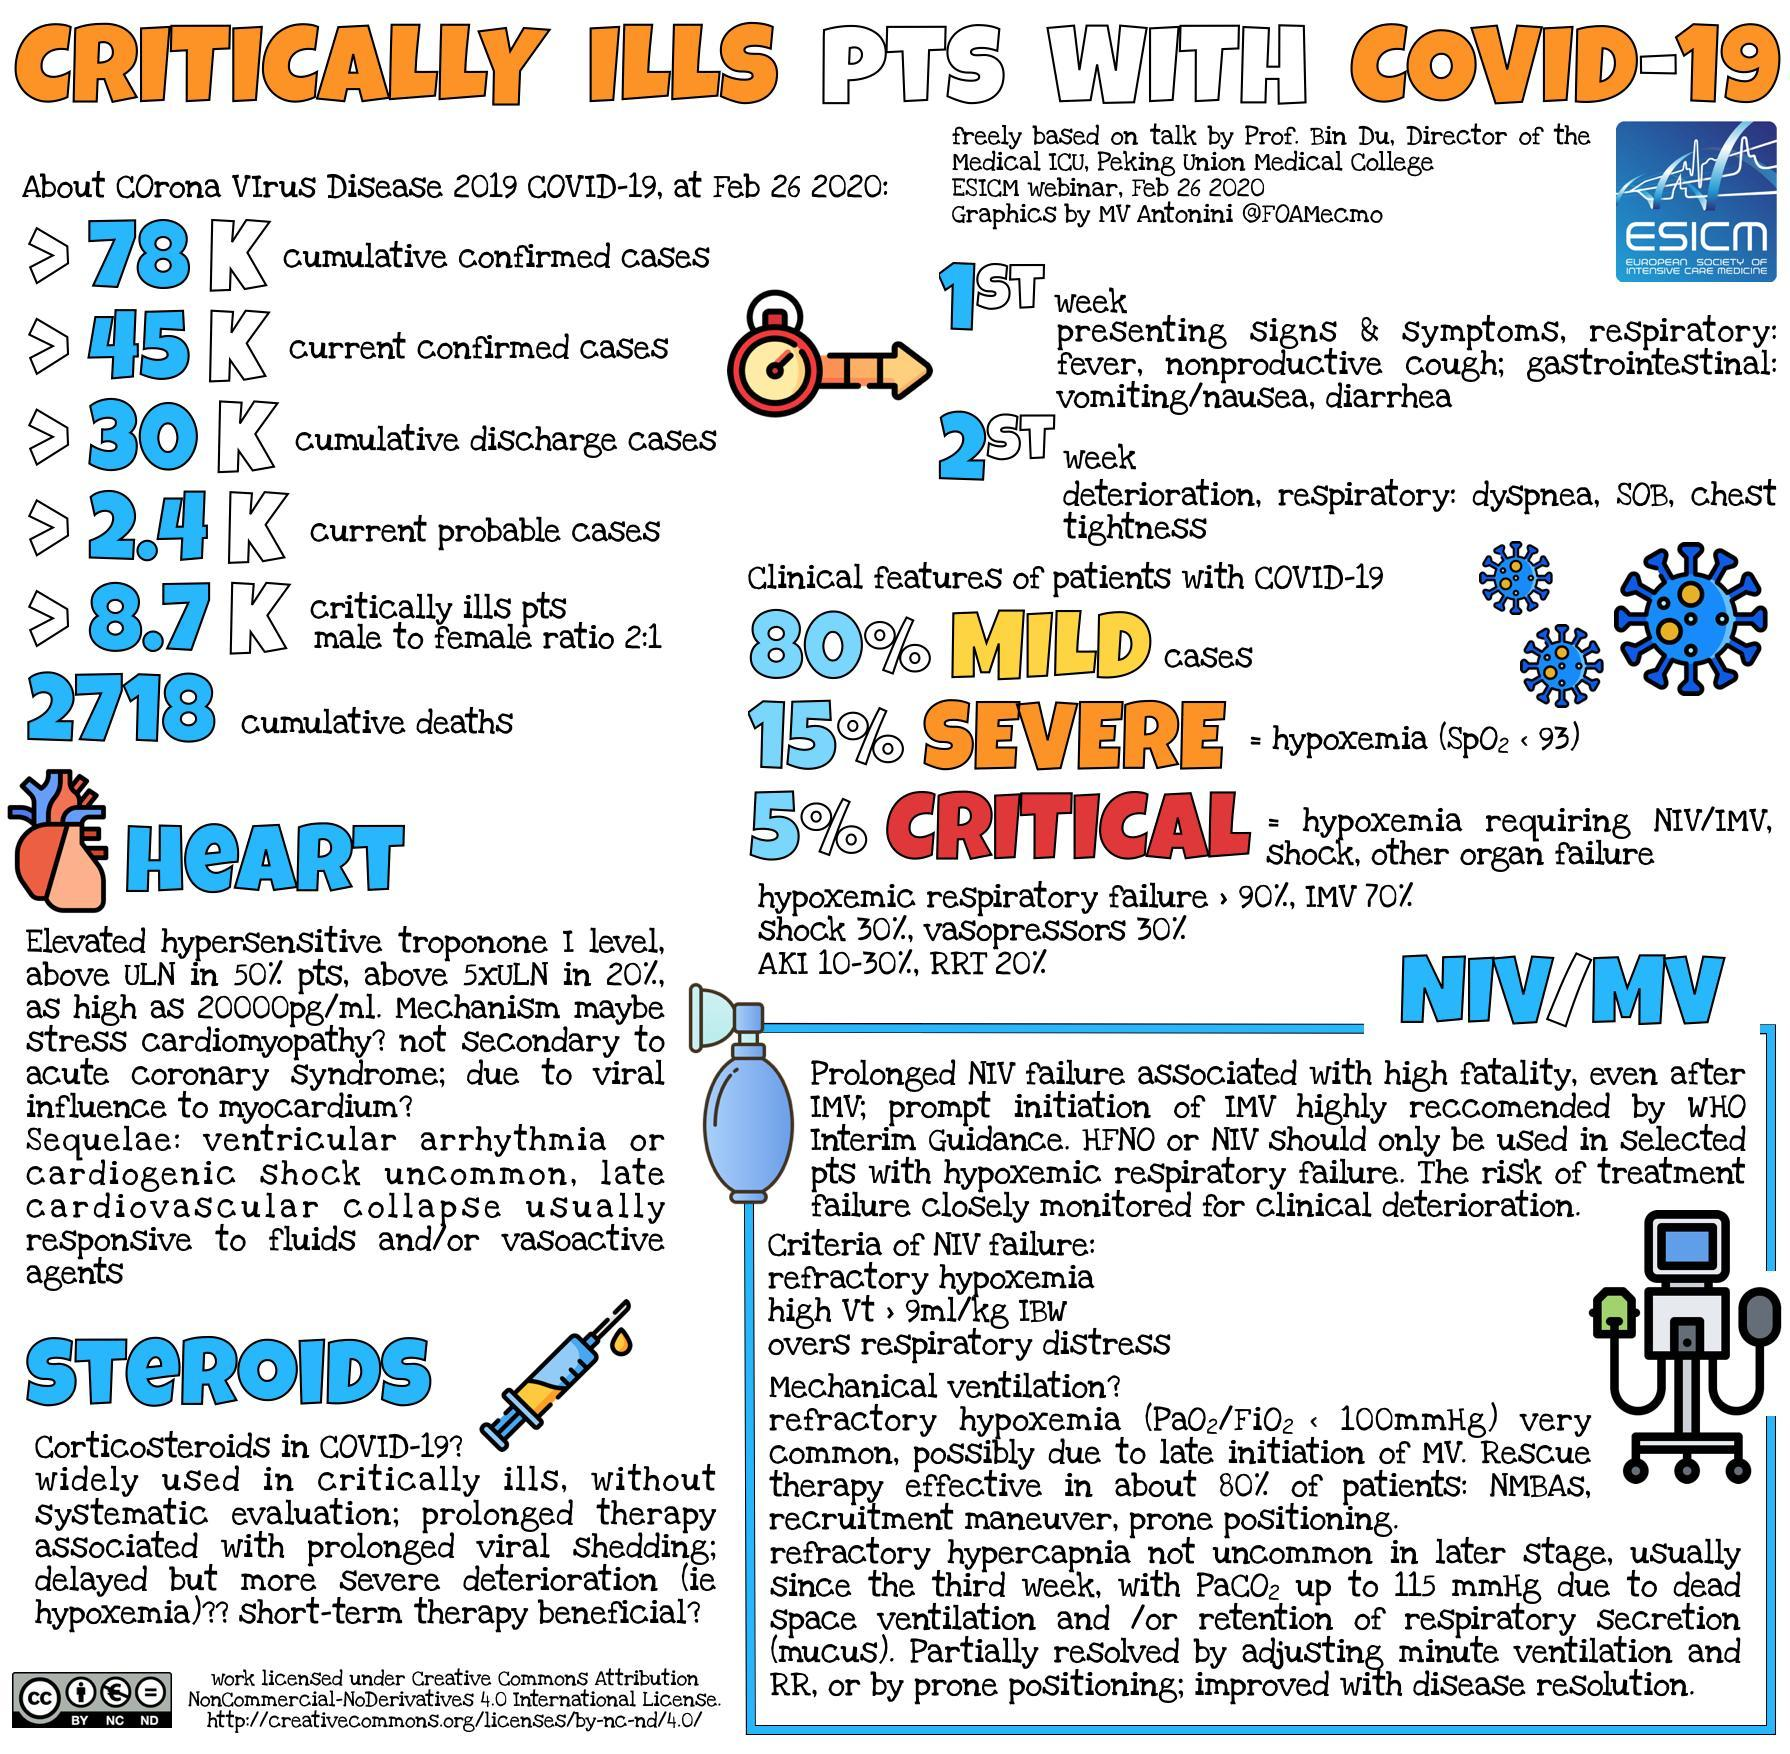What is the no of seriously ill patients expecting to be positive?
Answer the question with a short phrase. >2.4K What is the color code given to mild patients- green, white, yellow, red? yellow What percentage of corona patients are not going to extreme serious condition out of 8700? 95 How many seriously ill people have recovered and moved out of hospital? >30K What percentage of people went extreme serious condition? 5% What number of male patients are seriously ill and corona positive out of 8700? 5800 How many seriously ill people are corona positive at the present situation? >45k What number of female patients are seriously ill and corona positive? 2900 What is the saturation value of oxygen in acute patients? 93 What is the total no of people who died due to corona? 2718 